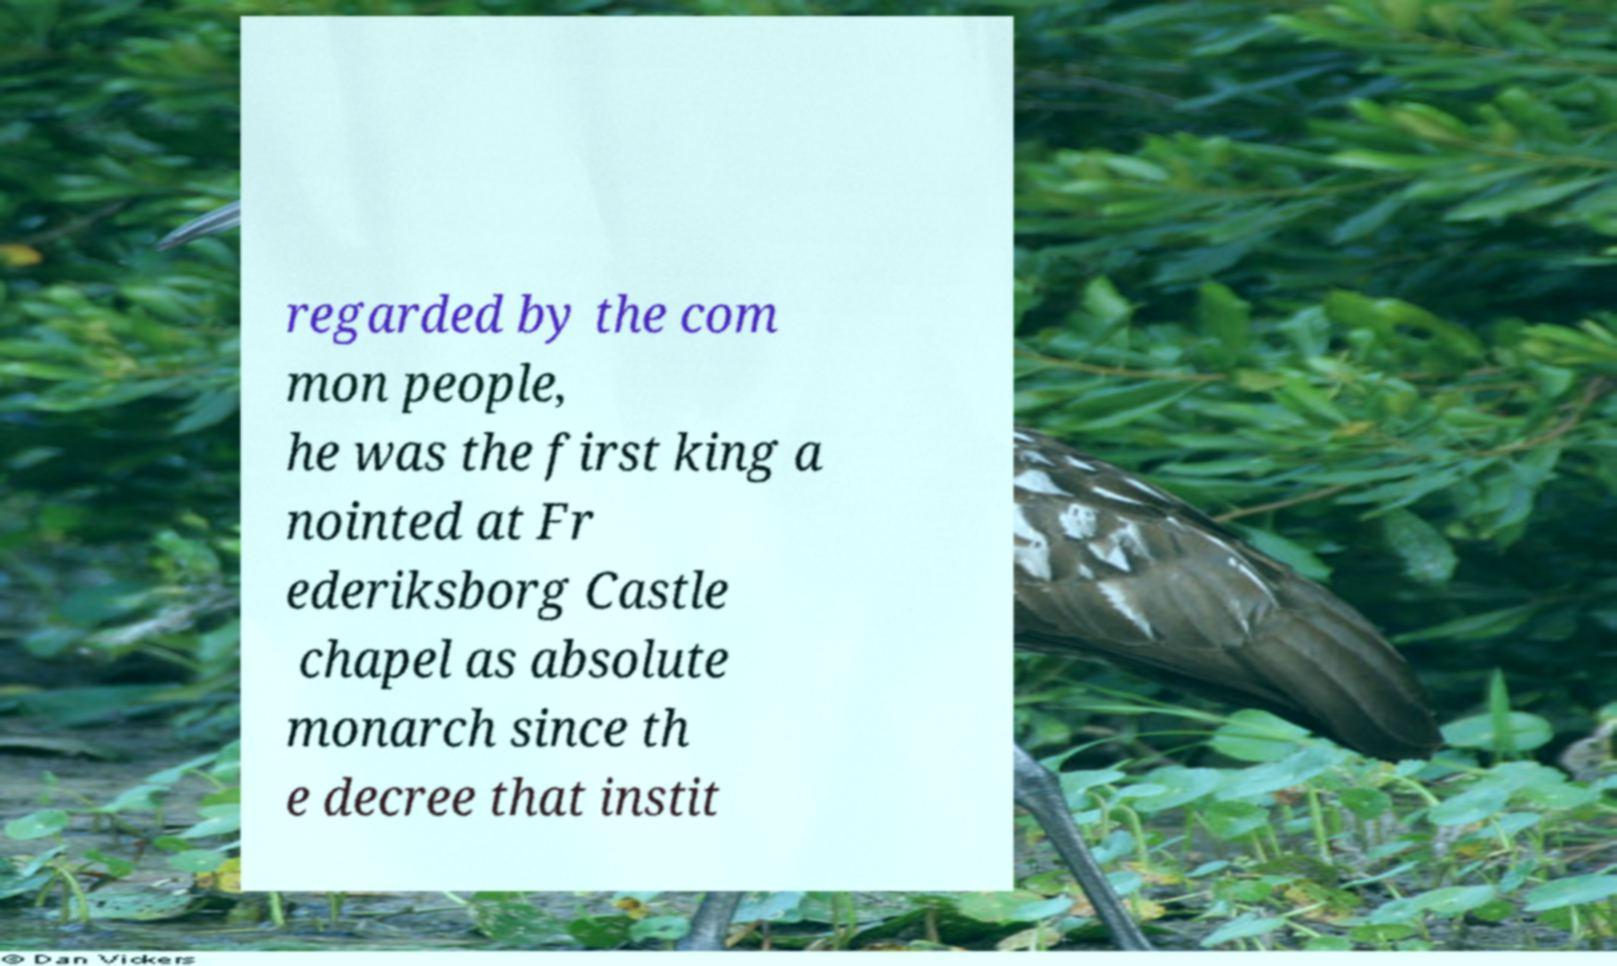There's text embedded in this image that I need extracted. Can you transcribe it verbatim? regarded by the com mon people, he was the first king a nointed at Fr ederiksborg Castle chapel as absolute monarch since th e decree that instit 